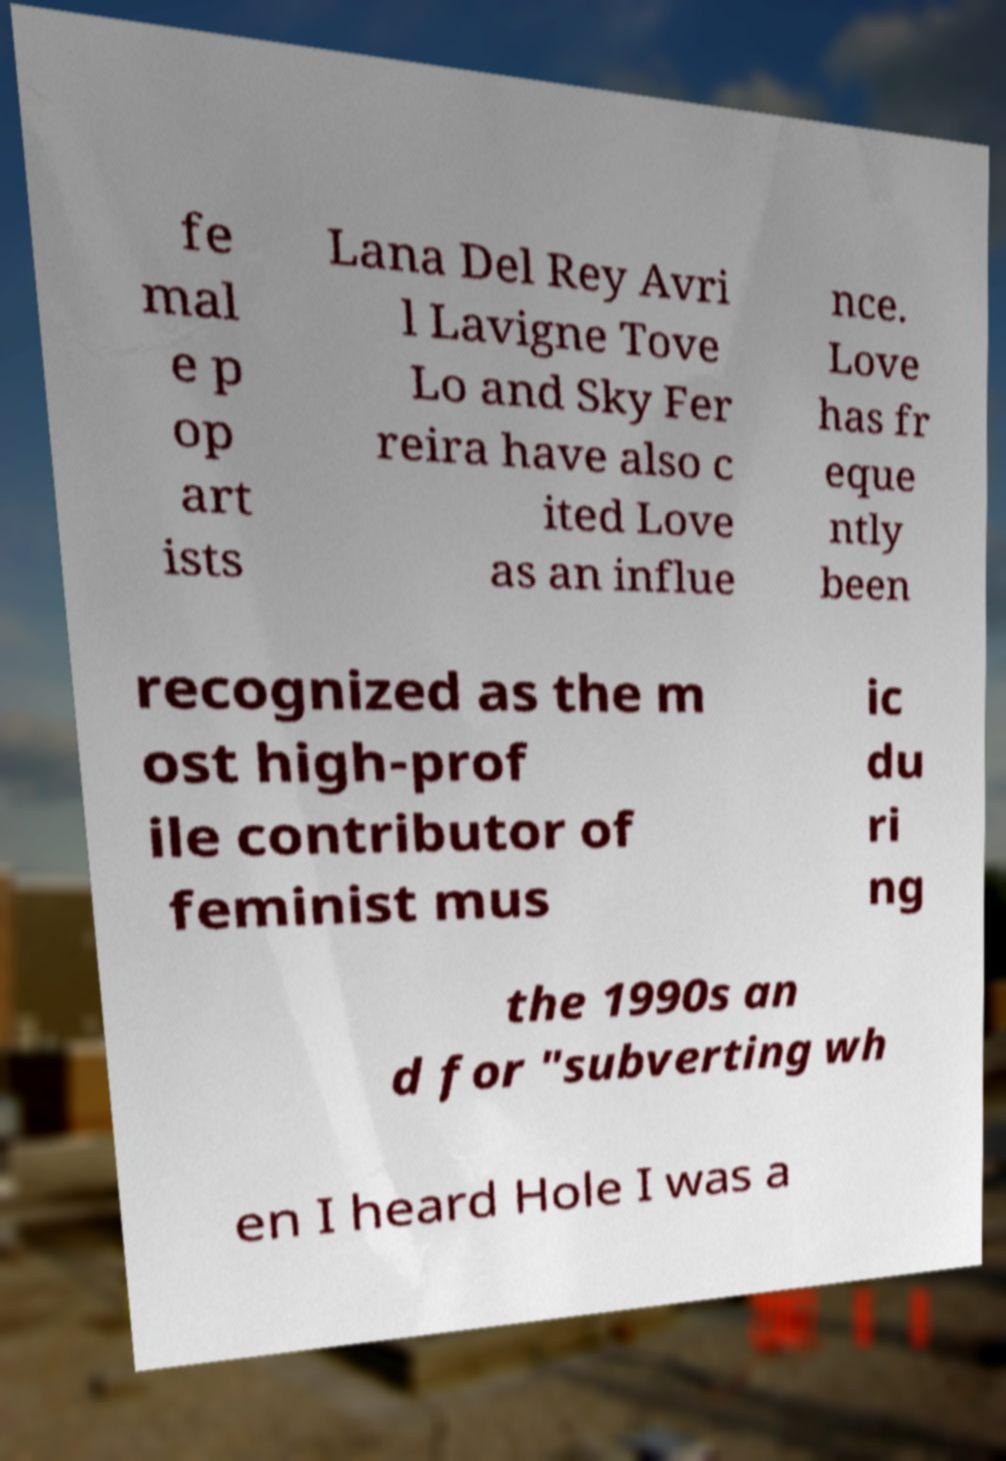I need the written content from this picture converted into text. Can you do that? fe mal e p op art ists Lana Del Rey Avri l Lavigne Tove Lo and Sky Fer reira have also c ited Love as an influe nce. Love has fr eque ntly been recognized as the m ost high-prof ile contributor of feminist mus ic du ri ng the 1990s an d for "subverting wh en I heard Hole I was a 